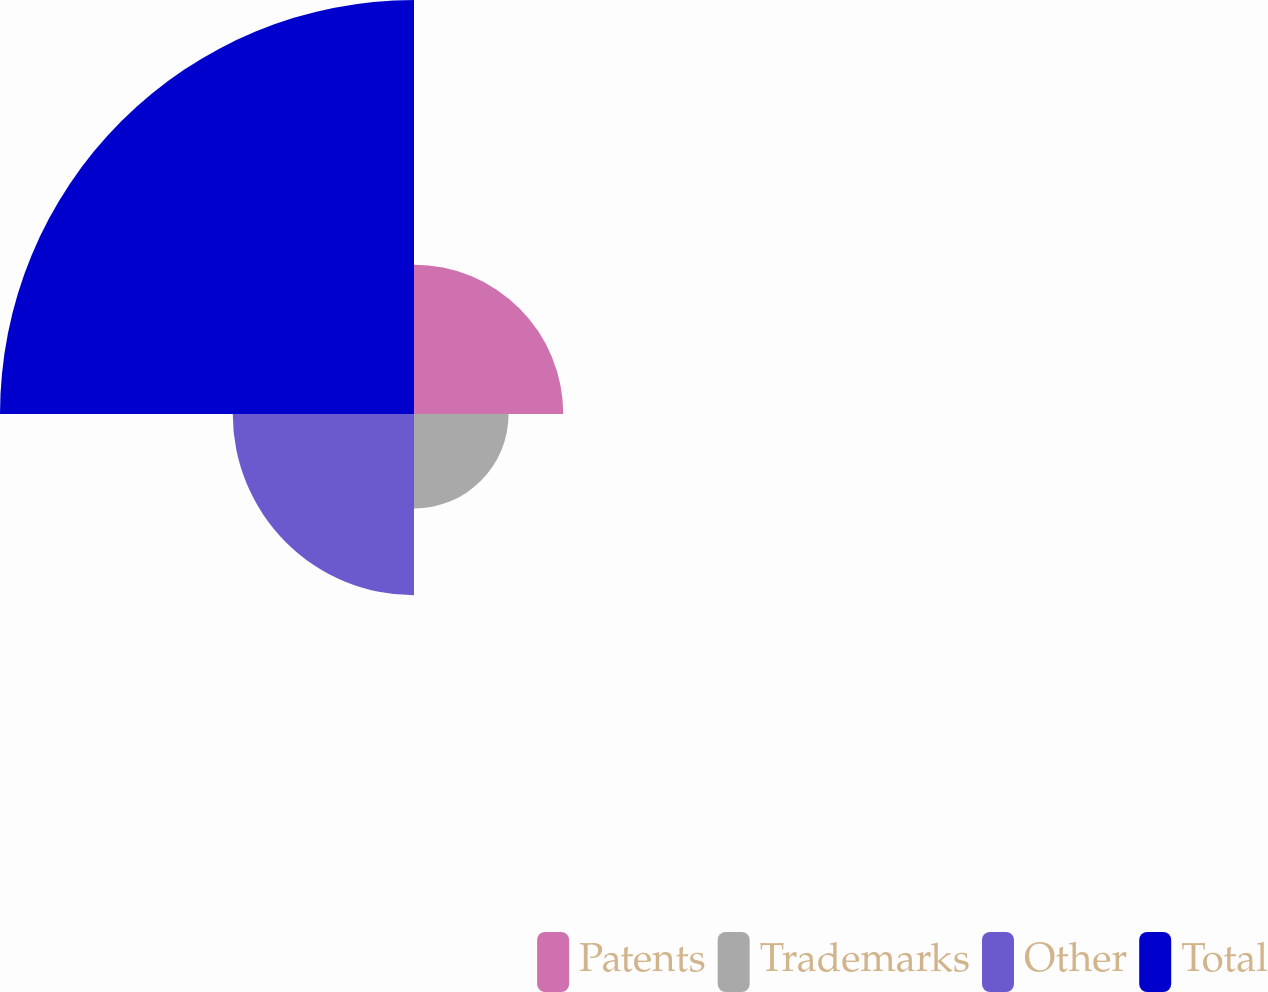Convert chart. <chart><loc_0><loc_0><loc_500><loc_500><pie_chart><fcel>Patents<fcel>Trademarks<fcel>Other<fcel>Total<nl><fcel>17.79%<fcel>11.27%<fcel>21.6%<fcel>49.34%<nl></chart> 